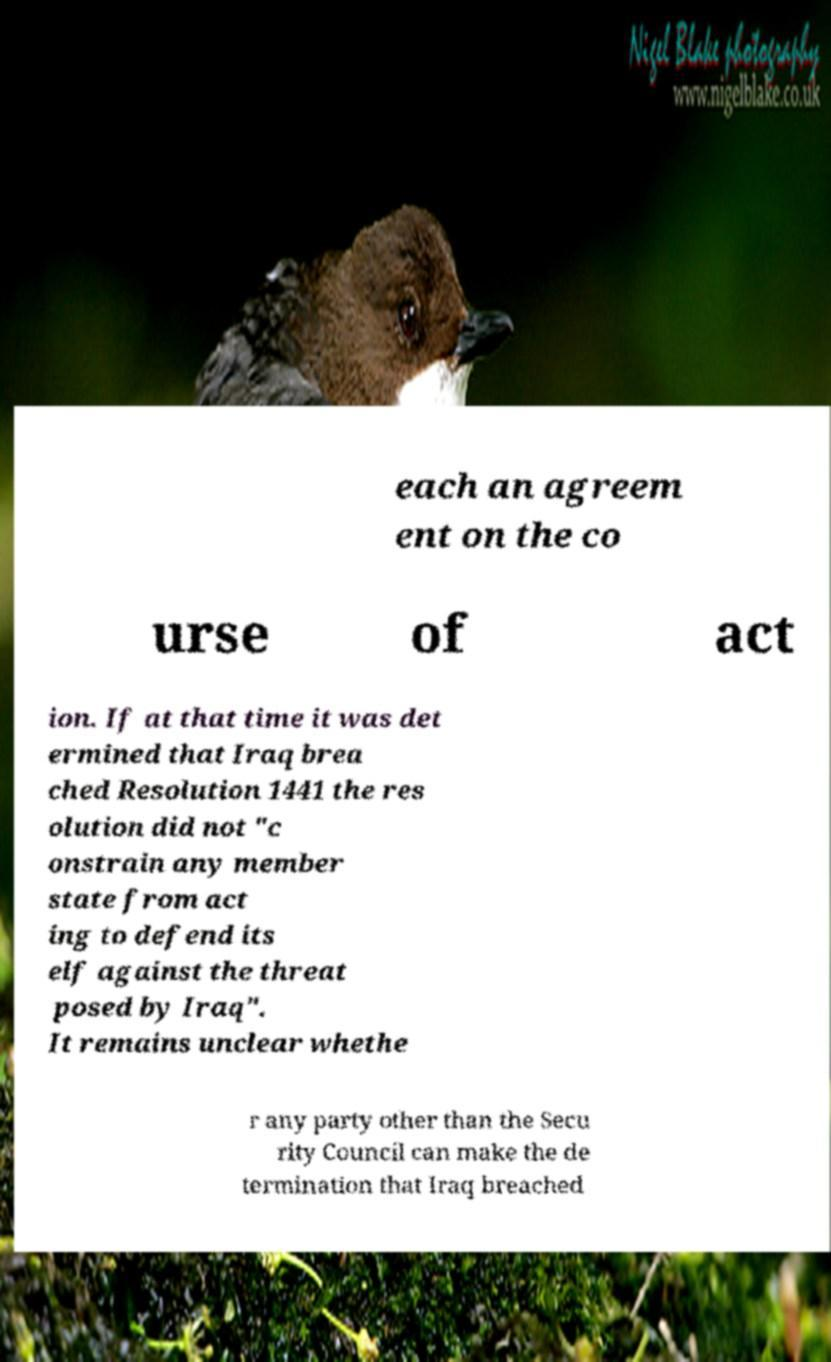There's text embedded in this image that I need extracted. Can you transcribe it verbatim? each an agreem ent on the co urse of act ion. If at that time it was det ermined that Iraq brea ched Resolution 1441 the res olution did not "c onstrain any member state from act ing to defend its elf against the threat posed by Iraq". It remains unclear whethe r any party other than the Secu rity Council can make the de termination that Iraq breached 